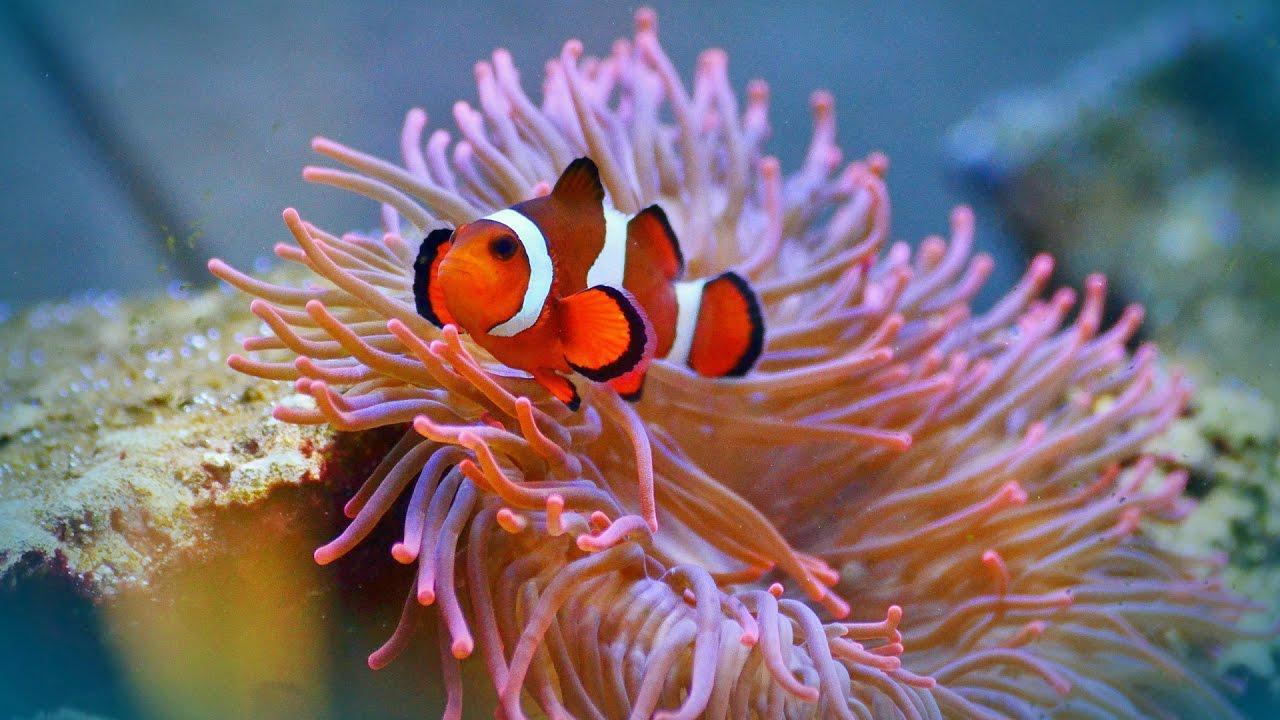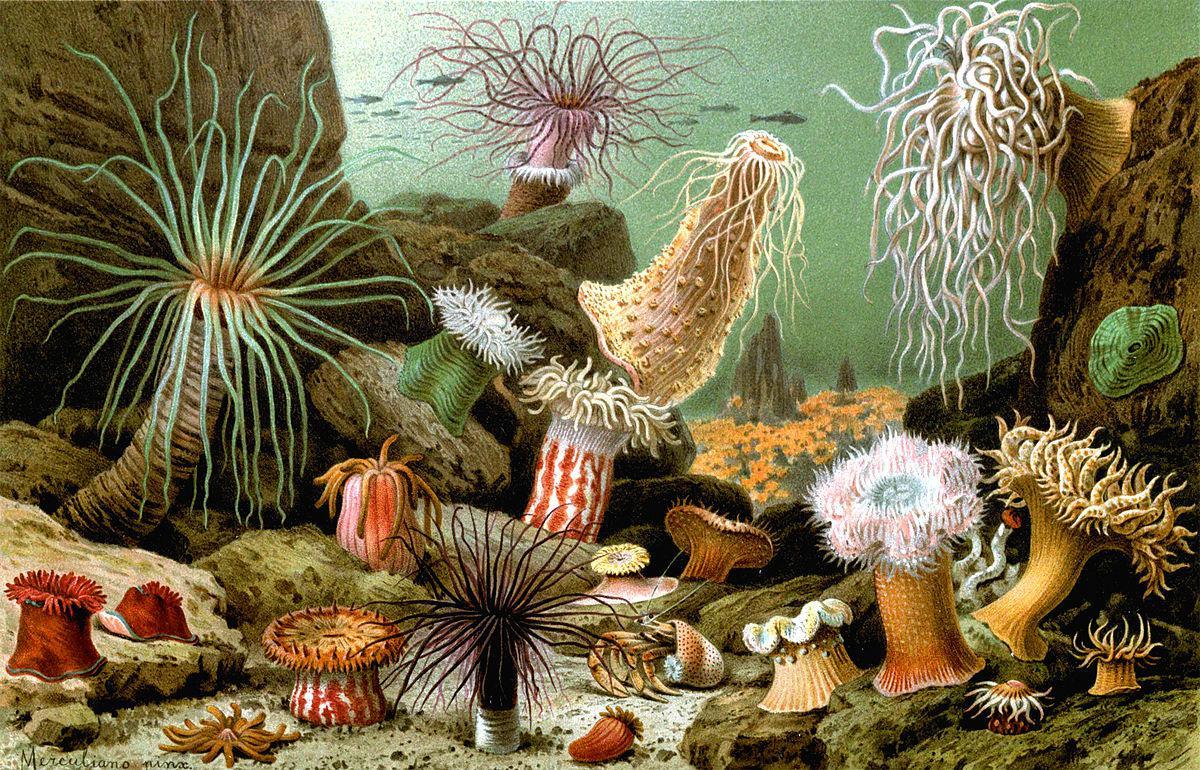The first image is the image on the left, the second image is the image on the right. Assess this claim about the two images: "At least one image shows a striped clown fish swimming among anemone tendrils.". Correct or not? Answer yes or no. Yes. 